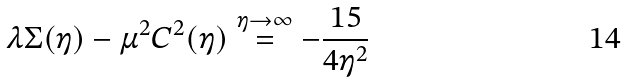<formula> <loc_0><loc_0><loc_500><loc_500>\lambda \Sigma ( \eta ) - \mu ^ { 2 } C ^ { 2 } ( \eta ) \stackrel { \eta \rightarrow \infty } { = } - \frac { 1 5 } { 4 \eta ^ { 2 } }</formula> 